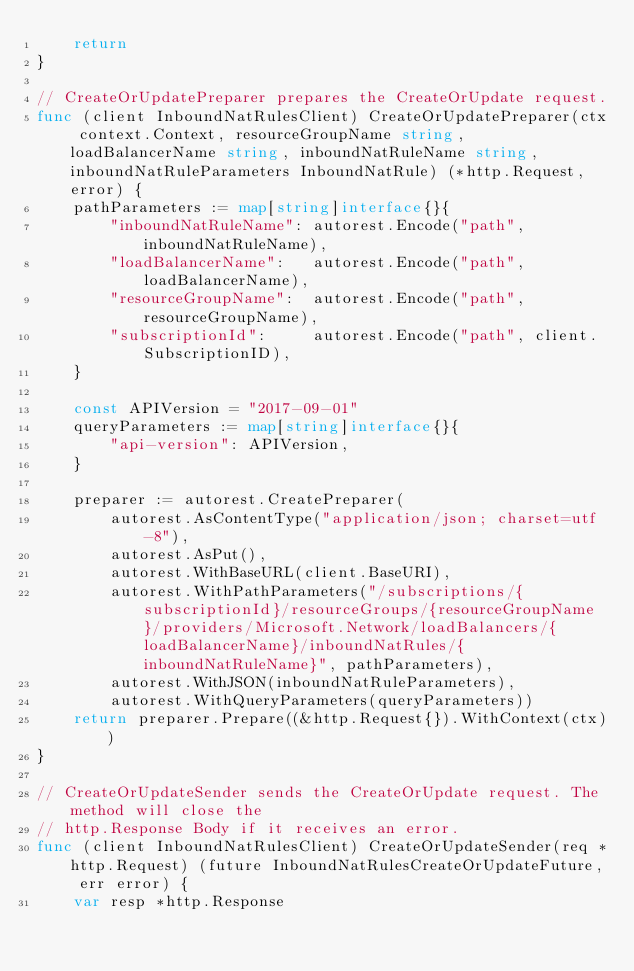<code> <loc_0><loc_0><loc_500><loc_500><_Go_>	return
}

// CreateOrUpdatePreparer prepares the CreateOrUpdate request.
func (client InboundNatRulesClient) CreateOrUpdatePreparer(ctx context.Context, resourceGroupName string, loadBalancerName string, inboundNatRuleName string, inboundNatRuleParameters InboundNatRule) (*http.Request, error) {
	pathParameters := map[string]interface{}{
		"inboundNatRuleName": autorest.Encode("path", inboundNatRuleName),
		"loadBalancerName":   autorest.Encode("path", loadBalancerName),
		"resourceGroupName":  autorest.Encode("path", resourceGroupName),
		"subscriptionId":     autorest.Encode("path", client.SubscriptionID),
	}

	const APIVersion = "2017-09-01"
	queryParameters := map[string]interface{}{
		"api-version": APIVersion,
	}

	preparer := autorest.CreatePreparer(
		autorest.AsContentType("application/json; charset=utf-8"),
		autorest.AsPut(),
		autorest.WithBaseURL(client.BaseURI),
		autorest.WithPathParameters("/subscriptions/{subscriptionId}/resourceGroups/{resourceGroupName}/providers/Microsoft.Network/loadBalancers/{loadBalancerName}/inboundNatRules/{inboundNatRuleName}", pathParameters),
		autorest.WithJSON(inboundNatRuleParameters),
		autorest.WithQueryParameters(queryParameters))
	return preparer.Prepare((&http.Request{}).WithContext(ctx))
}

// CreateOrUpdateSender sends the CreateOrUpdate request. The method will close the
// http.Response Body if it receives an error.
func (client InboundNatRulesClient) CreateOrUpdateSender(req *http.Request) (future InboundNatRulesCreateOrUpdateFuture, err error) {
	var resp *http.Response</code> 